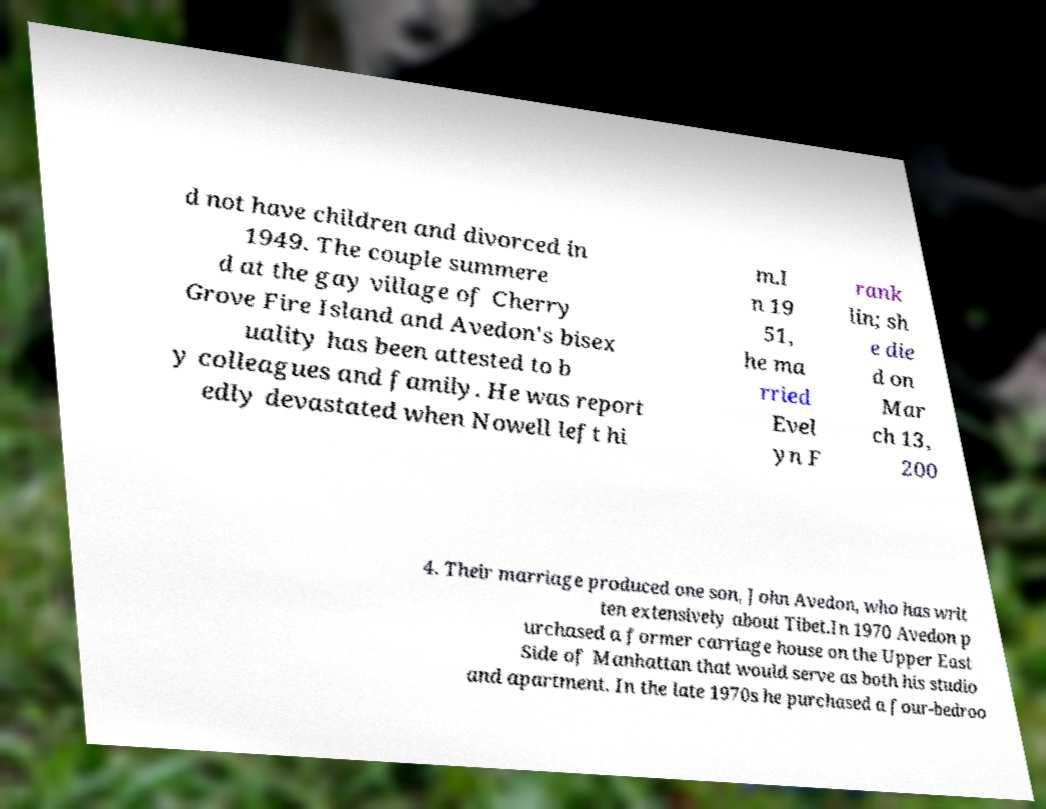Please read and relay the text visible in this image. What does it say? d not have children and divorced in 1949. The couple summere d at the gay village of Cherry Grove Fire Island and Avedon's bisex uality has been attested to b y colleagues and family. He was report edly devastated when Nowell left hi m.I n 19 51, he ma rried Evel yn F rank lin; sh e die d on Mar ch 13, 200 4. Their marriage produced one son, John Avedon, who has writ ten extensively about Tibet.In 1970 Avedon p urchased a former carriage house on the Upper East Side of Manhattan that would serve as both his studio and apartment. In the late 1970s he purchased a four-bedroo 